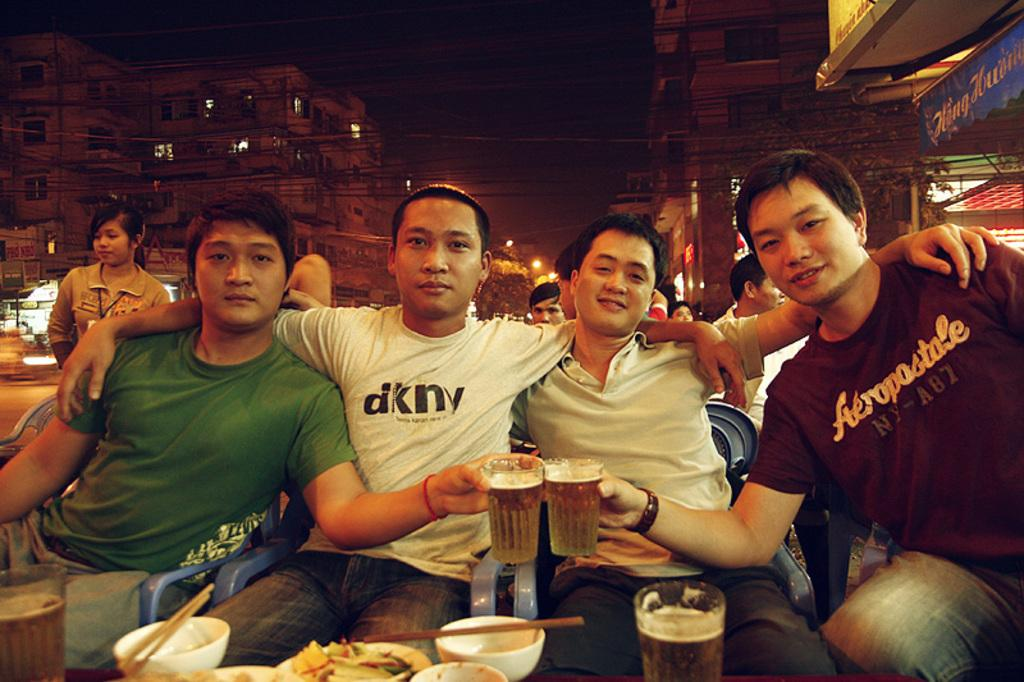How many people are seated in the image? There are four people seated on chairs in the image. What is the woman in the image doing? A woman is standing on the backs of the seated people. What can be seen in the background of the image? There are buildings visible in the image. What are the people holding in the image? The people in the image are holding glasses. What objects are on the table in the image? There are bowls on the table in the image. Can you describe the behavior of the lake in the image? There is no lake present in the image; it features four people seated on chairs, a woman standing on their backs, buildings in the background, and people holding glasses. What type of linen is draped over the table in the image? There is no linen present in the image; it features bowls on the table. 